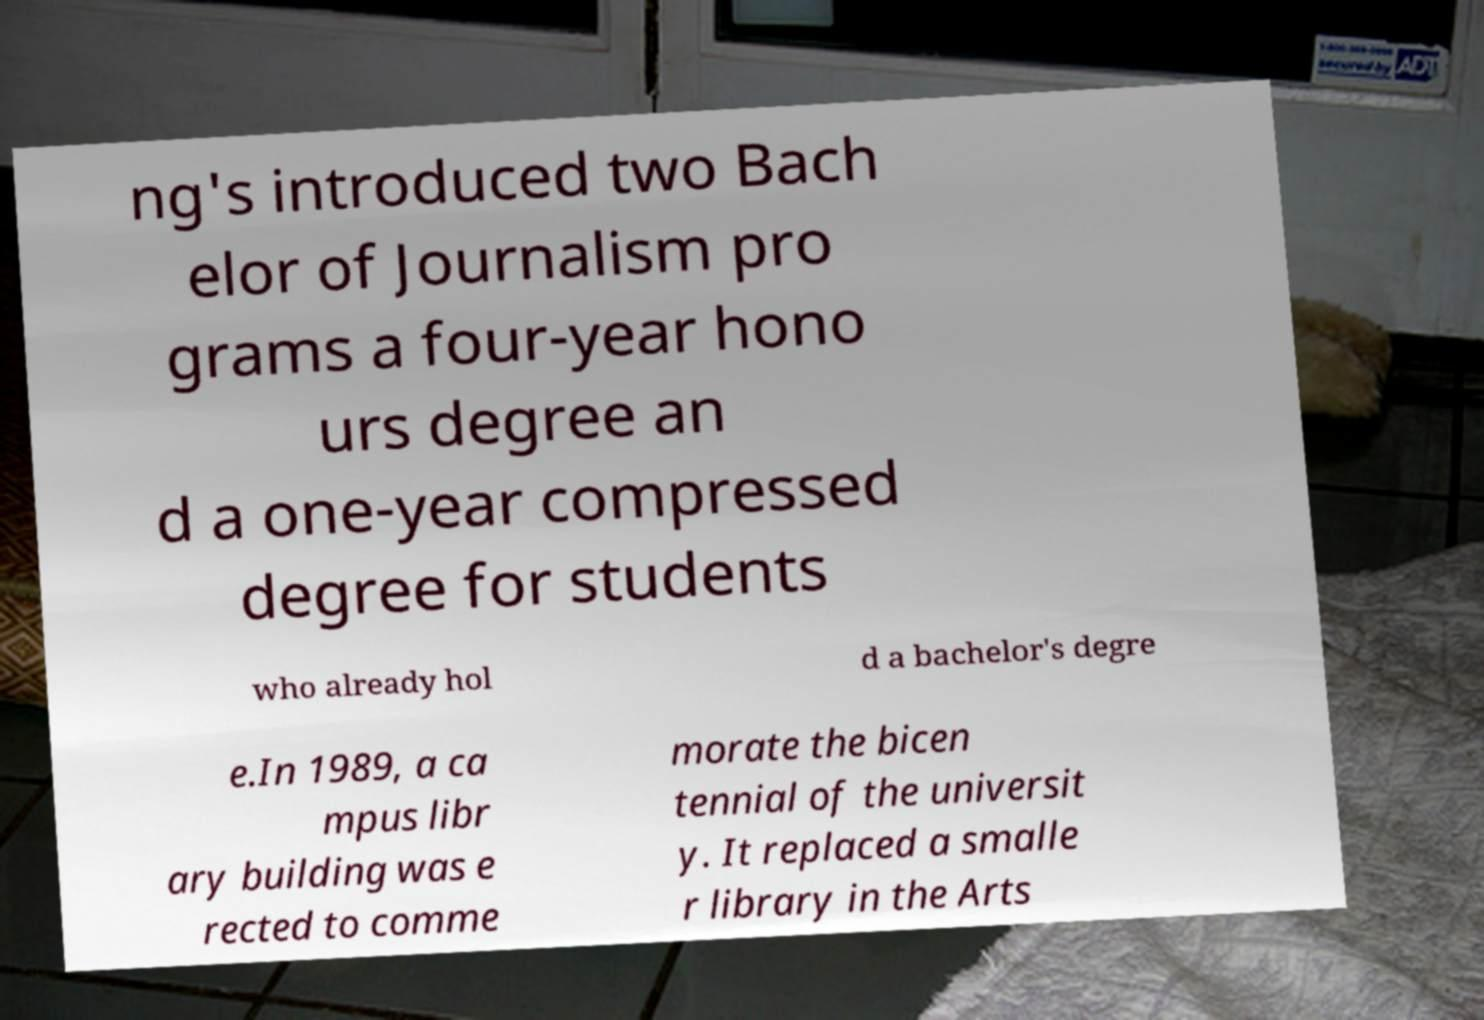There's text embedded in this image that I need extracted. Can you transcribe it verbatim? ng's introduced two Bach elor of Journalism pro grams a four-year hono urs degree an d a one-year compressed degree for students who already hol d a bachelor's degre e.In 1989, a ca mpus libr ary building was e rected to comme morate the bicen tennial of the universit y. It replaced a smalle r library in the Arts 